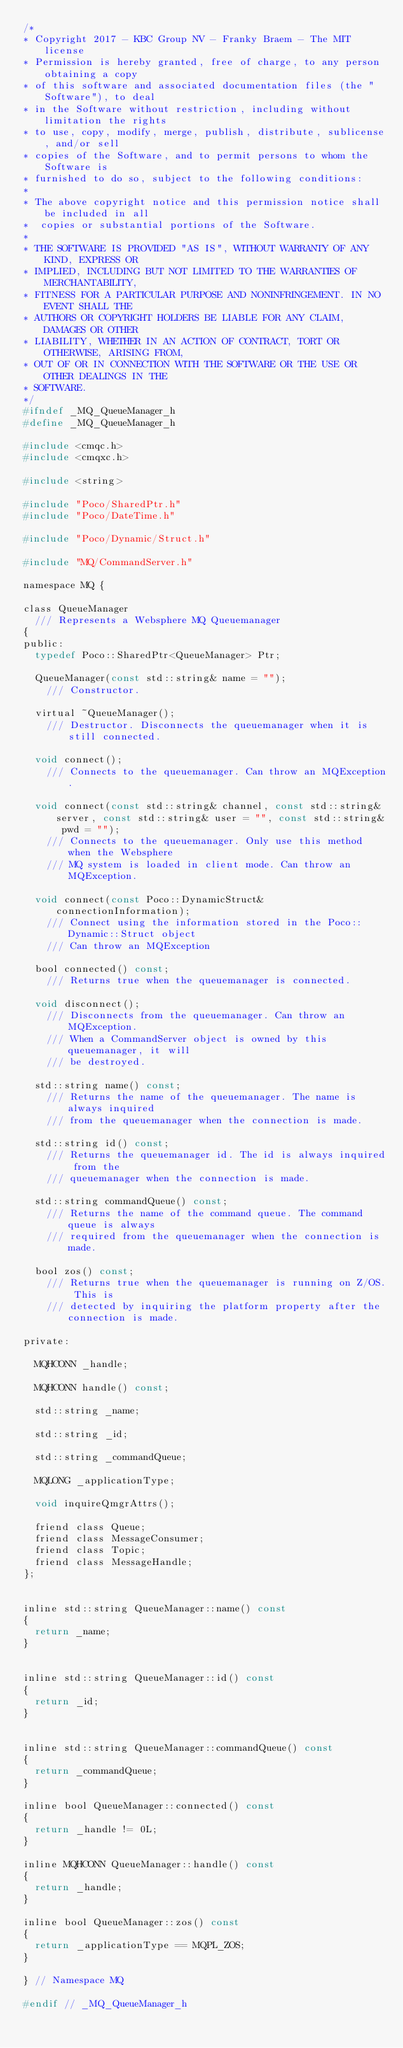Convert code to text. <code><loc_0><loc_0><loc_500><loc_500><_C_>/*
* Copyright 2017 - KBC Group NV - Franky Braem - The MIT license
* Permission is hereby granted, free of charge, to any person obtaining a copy
* of this software and associated documentation files (the "Software"), to deal
* in the Software without restriction, including without limitation the rights
* to use, copy, modify, merge, publish, distribute, sublicense, and/or sell
* copies of the Software, and to permit persons to whom the Software is
* furnished to do so, subject to the following conditions:
*
* The above copyright notice and this permission notice shall be included in all
*  copies or substantial portions of the Software.
*
* THE SOFTWARE IS PROVIDED "AS IS", WITHOUT WARRANTY OF ANY KIND, EXPRESS OR
* IMPLIED, INCLUDING BUT NOT LIMITED TO THE WARRANTIES OF MERCHANTABILITY,
* FITNESS FOR A PARTICULAR PURPOSE AND NONINFRINGEMENT. IN NO EVENT SHALL THE
* AUTHORS OR COPYRIGHT HOLDERS BE LIABLE FOR ANY CLAIM, DAMAGES OR OTHER
* LIABILITY, WHETHER IN AN ACTION OF CONTRACT, TORT OR OTHERWISE, ARISING FROM,
* OUT OF OR IN CONNECTION WITH THE SOFTWARE OR THE USE OR OTHER DEALINGS IN THE
* SOFTWARE.
*/
#ifndef _MQ_QueueManager_h
#define _MQ_QueueManager_h

#include <cmqc.h>
#include <cmqxc.h>

#include <string>

#include "Poco/SharedPtr.h"
#include "Poco/DateTime.h"

#include "Poco/Dynamic/Struct.h"

#include "MQ/CommandServer.h"

namespace MQ {

class QueueManager
	/// Represents a Websphere MQ Queuemanager
{
public:
	typedef Poco::SharedPtr<QueueManager> Ptr;

	QueueManager(const std::string& name = "");
		/// Constructor.

	virtual ~QueueManager();
		/// Destructor. Disconnects the queuemanager when it is still connected.

	void connect();
		/// Connects to the queuemanager. Can throw an MQException.

	void connect(const std::string& channel, const std::string& server, const std::string& user = "", const std::string& pwd = "");
		/// Connects to the queuemanager. Only use this method when the Websphere
		/// MQ system is loaded in client mode. Can throw an MQException.

	void connect(const Poco::DynamicStruct& connectionInformation);
		/// Connect using the information stored in the Poco::Dynamic::Struct object
		/// Can throw an MQException

	bool connected() const;
		/// Returns true when the queuemanager is connected.

	void disconnect();
		/// Disconnects from the queuemanager. Can throw an MQException.
		/// When a CommandServer object is owned by this queuemanager, it will
		/// be destroyed.

	std::string name() const;
		/// Returns the name of the queuemanager. The name is always inquired
		/// from the queuemanager when the connection is made.

	std::string id() const;
		/// Returns the queuemanager id. The id is always inquired from the
		/// queuemanager when the connection is made.

	std::string commandQueue() const;
		/// Returns the name of the command queue. The command queue is always
		/// required from the queuemanager when the connection is made.

	bool zos() const;
		/// Returns true when the queuemanager is running on Z/OS. This is
		/// detected by inquiring the platform property after the connection is made.

private:

	MQHCONN _handle;

	MQHCONN handle() const;

	std::string _name;

	std::string _id;

	std::string _commandQueue;

	MQLONG _applicationType;

	void inquireQmgrAttrs();

	friend class Queue;
	friend class MessageConsumer;
	friend class Topic;
	friend class MessageHandle;
};


inline std::string QueueManager::name() const
{
	return _name;
}


inline std::string QueueManager::id() const
{
	return _id;
}


inline std::string QueueManager::commandQueue() const
{
	return _commandQueue;
}

inline bool QueueManager::connected() const
{
	return _handle != 0L;
}

inline MQHCONN QueueManager::handle() const
{
	return _handle;
}

inline bool QueueManager::zos() const
{
	return _applicationType == MQPL_ZOS;
}

} // Namespace MQ

#endif // _MQ_QueueManager_h
</code> 